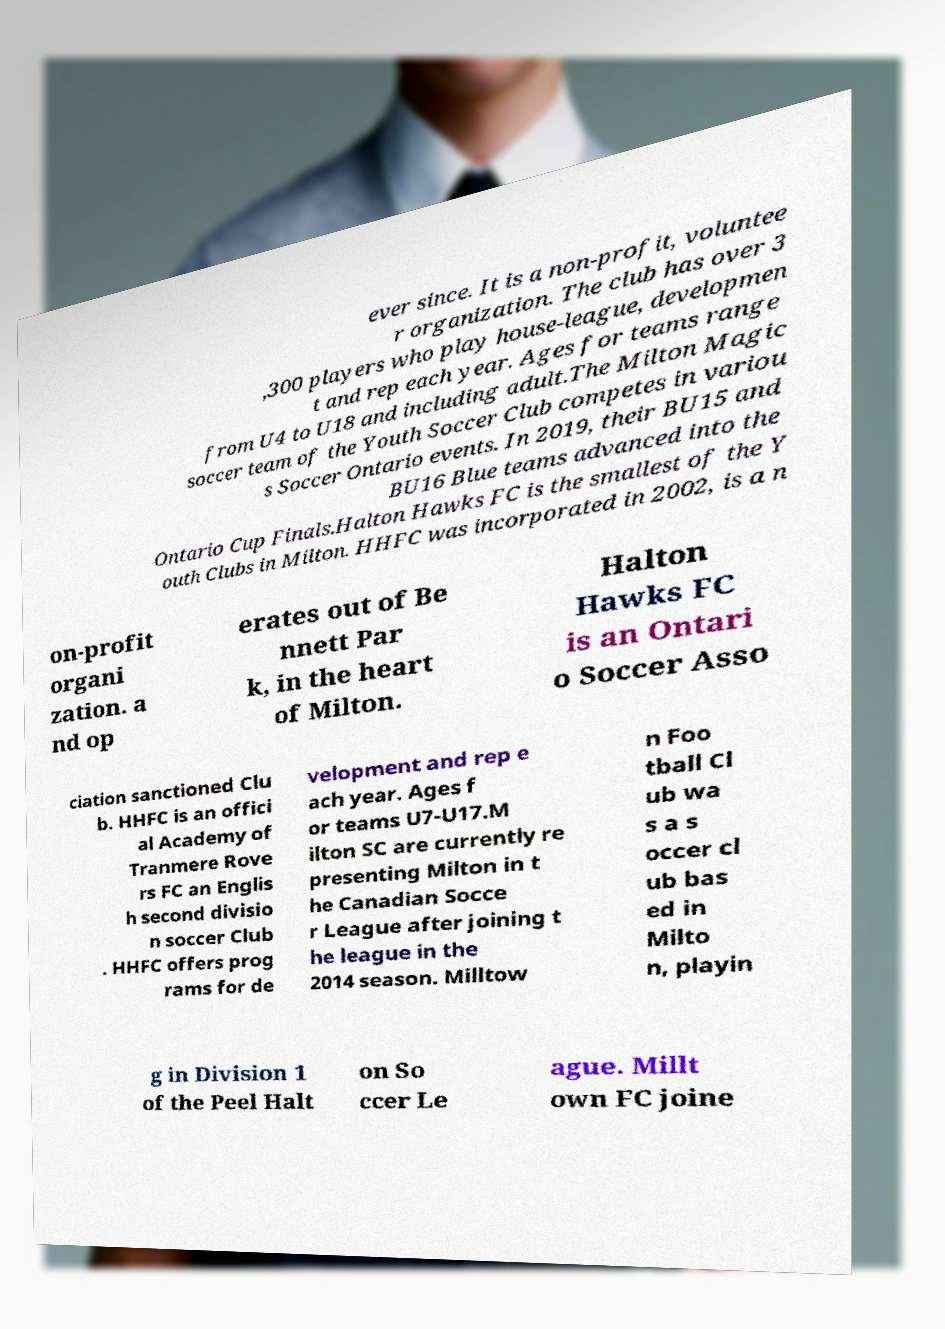For documentation purposes, I need the text within this image transcribed. Could you provide that? ever since. It is a non-profit, voluntee r organization. The club has over 3 ,300 players who play house-league, developmen t and rep each year. Ages for teams range from U4 to U18 and including adult.The Milton Magic soccer team of the Youth Soccer Club competes in variou s Soccer Ontario events. In 2019, their BU15 and BU16 Blue teams advanced into the Ontario Cup Finals.Halton Hawks FC is the smallest of the Y outh Clubs in Milton. HHFC was incorporated in 2002, is a n on-profit organi zation. a nd op erates out of Be nnett Par k, in the heart of Milton. Halton Hawks FC is an Ontari o Soccer Asso ciation sanctioned Clu b. HHFC is an offici al Academy of Tranmere Rove rs FC an Englis h second divisio n soccer Club . HHFC offers prog rams for de velopment and rep e ach year. Ages f or teams U7-U17.M ilton SC are currently re presenting Milton in t he Canadian Socce r League after joining t he league in the 2014 season. Milltow n Foo tball Cl ub wa s a s occer cl ub bas ed in Milto n, playin g in Division 1 of the Peel Halt on So ccer Le ague. Millt own FC joine 